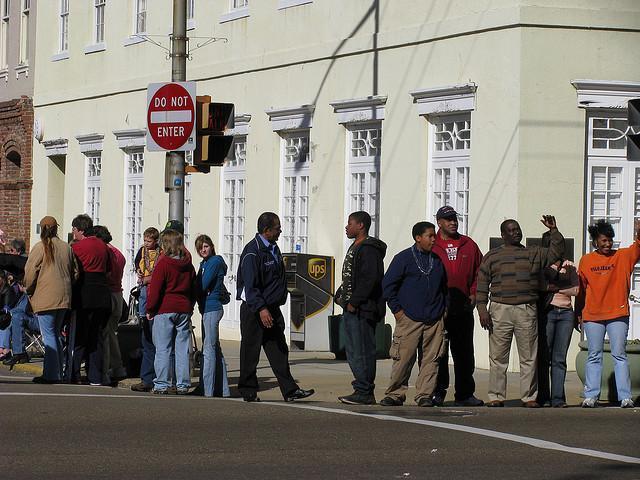How many people dressed in red?
Give a very brief answer. 3. How many people can be seen?
Give a very brief answer. 12. 